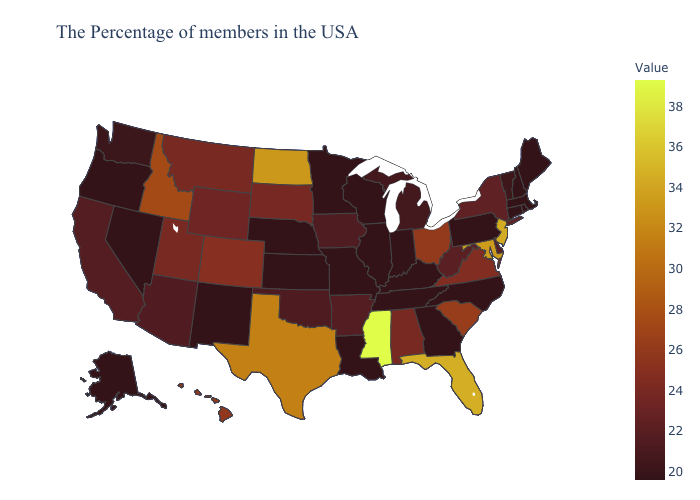Does Connecticut have the lowest value in the Northeast?
Write a very short answer. Yes. Does Idaho have the highest value in the West?
Short answer required. Yes. Does Mississippi have the highest value in the USA?
Give a very brief answer. Yes. Does Idaho have the highest value in the West?
Short answer required. Yes. 